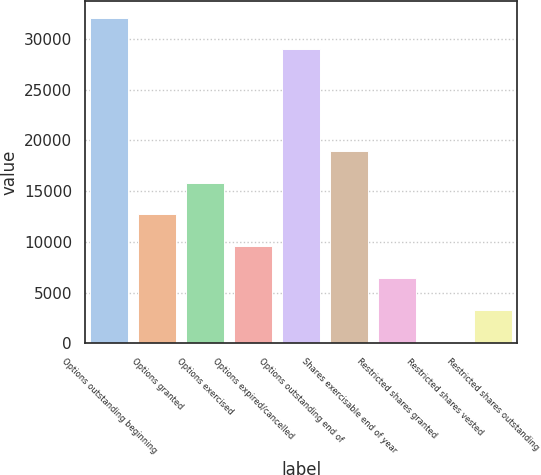<chart> <loc_0><loc_0><loc_500><loc_500><bar_chart><fcel>Options outstanding beginning<fcel>Options granted<fcel>Options exercised<fcel>Options expired/cancelled<fcel>Options outstanding end of<fcel>Shares exercisable end of year<fcel>Restricted shares granted<fcel>Restricted shares vested<fcel>Restricted shares outstanding<nl><fcel>32104<fcel>12704<fcel>15844<fcel>9564<fcel>28964<fcel>18984<fcel>6424<fcel>144<fcel>3284<nl></chart> 